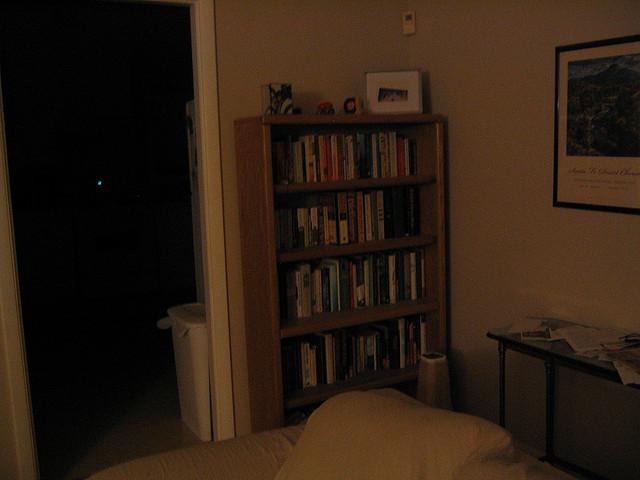How many books can you see?
Concise answer only. 100. Is this color or white and black image?
Concise answer only. Color. Is there a lamp in the room?
Write a very short answer. No. Is the photo taken during the day or at night?
Answer briefly. Night. What color is the trash can?
Quick response, please. White. What is in the book?
Quick response, please. Words. Is there any TV in the room?
Short answer required. No. Is the door open?
Short answer required. Yes. What brand shoe is the dog sitting on?
Quick response, please. None. What is the normal use of the large object in the picture?
Be succinct. Bookshelf. What room is this?
Quick response, please. Living room. What is hanging on the back wall?
Be succinct. Picture. Is the light on?
Answer briefly. No. What color is the wall?
Answer briefly. Tan. What is on the wall?
Concise answer only. Picture. What is on the walls?
Short answer required. Picture. How many bookcases are there?
Give a very brief answer. 1. Is this a flower?
Concise answer only. No. What color is the chair?
Answer briefly. White. Are these books part of a private collection?
Answer briefly. Yes. What time of day is it?
Concise answer only. Night. Is there any window in there in this room?
Write a very short answer. No. How many pictures are hanging on the wall?
Be succinct. 1. Is the room cluttered?
Write a very short answer. No. What's on the wall?
Short answer required. Picture. What casts a shadow?
Write a very short answer. Light. What are the things that look similar which sit on the desk?
Keep it brief. Books. Is this a normal artwork for the room?
Be succinct. Yes. Can you see a light?
Quick response, please. No. Was this photo taken during the day?
Short answer required. No. Is the brown item a toy?
Be succinct. No. How many beds are in the bedroom?
Give a very brief answer. 1. What type of photograph is this?
Be succinct. Color. Is it nighttime?
Give a very brief answer. Yes. Are any lights on?
Keep it brief. No. Is the room a mess?
Be succinct. No. What's on top of the cupboard?
Short answer required. Frame. Is this safe?
Answer briefly. Yes. Is there an entertainment center in the room?
Short answer required. No. Is it day time?
Short answer required. No. What is the book laying on?
Concise answer only. Table. How many shelves are visible?
Short answer required. 4. What is hanging on the wall?
Answer briefly. Picture. Is it night time?
Quick response, please. Yes. What color is the basket?
Write a very short answer. White. How many books are in the picture?
Quick response, please. 100. What is it so dark in this room?
Keep it brief. Lights are off. Can I buy a bathrobe here?
Keep it brief. No. If you are in this room, you are behind what?
Quick response, please. Couch. Are there windows in this room?
Answer briefly. No. Is this a conference room?
Give a very brief answer. No. Most of the books are about what animal?
Keep it brief. Dogs. What kind of picture is on the wall?
Write a very short answer. Painting. Are there blinds in this image?
Write a very short answer. No. Is this in a home or restaurant?
Write a very short answer. Home. Where is the piece of cardboard?
Concise answer only. Floor. How many books are there?
Short answer required. 40. Is the light on in the closet?
Be succinct. No. Are these hardcover or softcover books?
Be succinct. Hardcover. Is it daylight in this image?
Concise answer only. No. What is the color of the dog?
Keep it brief. Black. Is it daylight outside?
Quick response, please. No. How many books are open?
Be succinct. 0. What is the picture on the wall?
Concise answer only. Framed. What color is the bin?
Keep it brief. White. Do you think this image is creepy?
Concise answer only. No. Can you see a reflection in this picture?
Be succinct. No. How many books?
Keep it brief. 60. Is both rooms dark?
Keep it brief. Yes. How many squares are on the poster?
Concise answer only. 1. Does the person who lives in this room read a lot?
Give a very brief answer. Yes. What Is the brown object?
Keep it brief. Shelf. What color is the carpet?
Concise answer only. Gray. Is this copyrighted?
Keep it brief. No. Is there a teddy bear in the photo?
Answer briefly. No. Is there a smoke alarm in the photo?
Keep it brief. Yes. Are there plants in the image?
Be succinct. No. What colors stand out?
Be succinct. White. Is this a hotel room?
Short answer required. No. Is it daytime outside?
Keep it brief. No. What is this person cutting with a knife?
Write a very short answer. Nothing. What Number of books are on the shelf?
Short answer required. 100. Is there a window in this room?
Answer briefly. No. Is the room colorful?
Answer briefly. No. What is shown on the decals on the storage areas?
Keep it brief. Nothing. How many pictures on the wall?
Be succinct. 1. Why is the desk so close to the sofa?
Short answer required. Convenience. How many books are in the volume?
Keep it brief. 40. How many books do you see?
Give a very brief answer. 100. What color are the walls?
Answer briefly. Tan. Is it daytime?
Concise answer only. No. What kind of picture is hanging on the wall?
Give a very brief answer. Art print. Is this a library?
Short answer required. No. Are the lights turned on?
Write a very short answer. No. Is someone traveling?
Write a very short answer. No. Is the picture taken inside?
Give a very brief answer. Yes. Are these all the same shape?
Be succinct. No. Is this a ribbon?
Concise answer only. No. What built-in appliance is shown in the upper-left corner?
Answer briefly. 0. What are these items used for?
Give a very brief answer. Reading. 